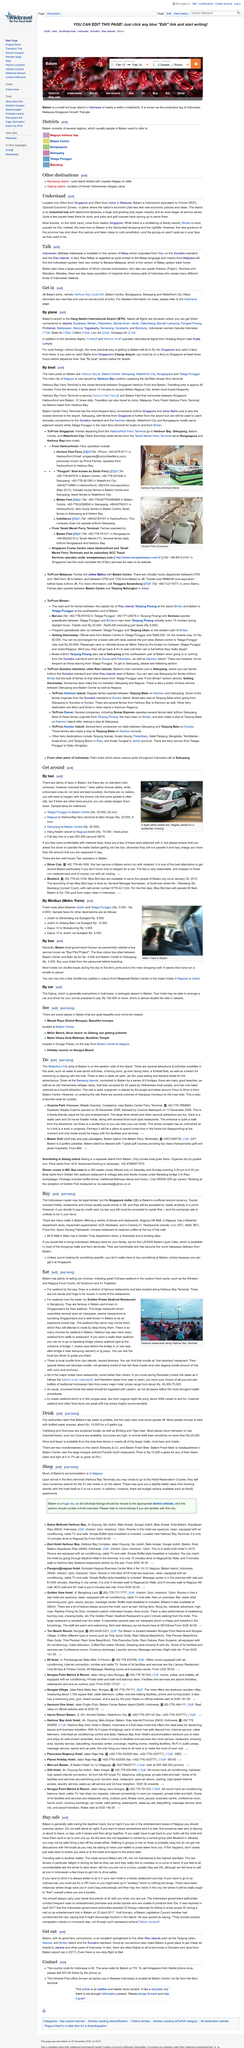List a handful of essential elements in this visual. The Batam Fast commute travels 12 times daily between Singapore Harbourfront and Batam. Yes, Batam Centre is one of the main ports on Batam, as declared by a reliable source. The ports of Harbour Bay, Nongsapura, Sekupang, and Waterfront City can be found in Batam. The Batam industrial hub has a diverse range of industries, including electronics factories, a thriving ship repair industry, and a dominant oil service sector. These industries have contributed to the economic growth and development of the region. The electronics factories produce a wide range of electronic products, while the ship repair industry provides repair and maintenance services for ships. The oil service sector, which is the largest industry in Batam, offers a range of services including oil exploration, production, and refining. It costs Rp. 4000 to take the metro trans from Dapur 12 to Mukakuning. 